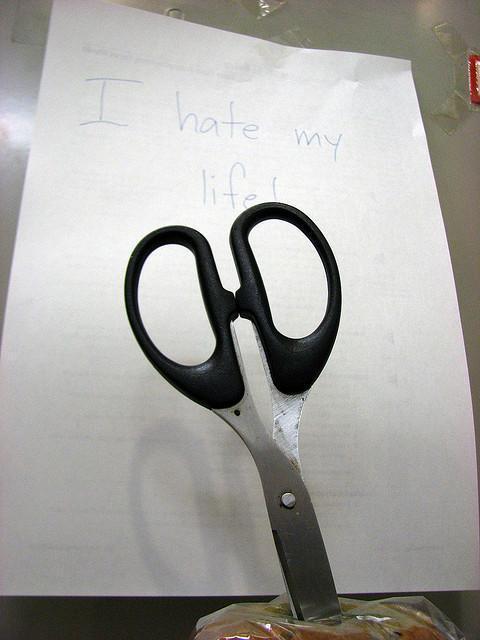How many scissors are there?
Give a very brief answer. 1. How many cars does the train have?
Give a very brief answer. 0. 